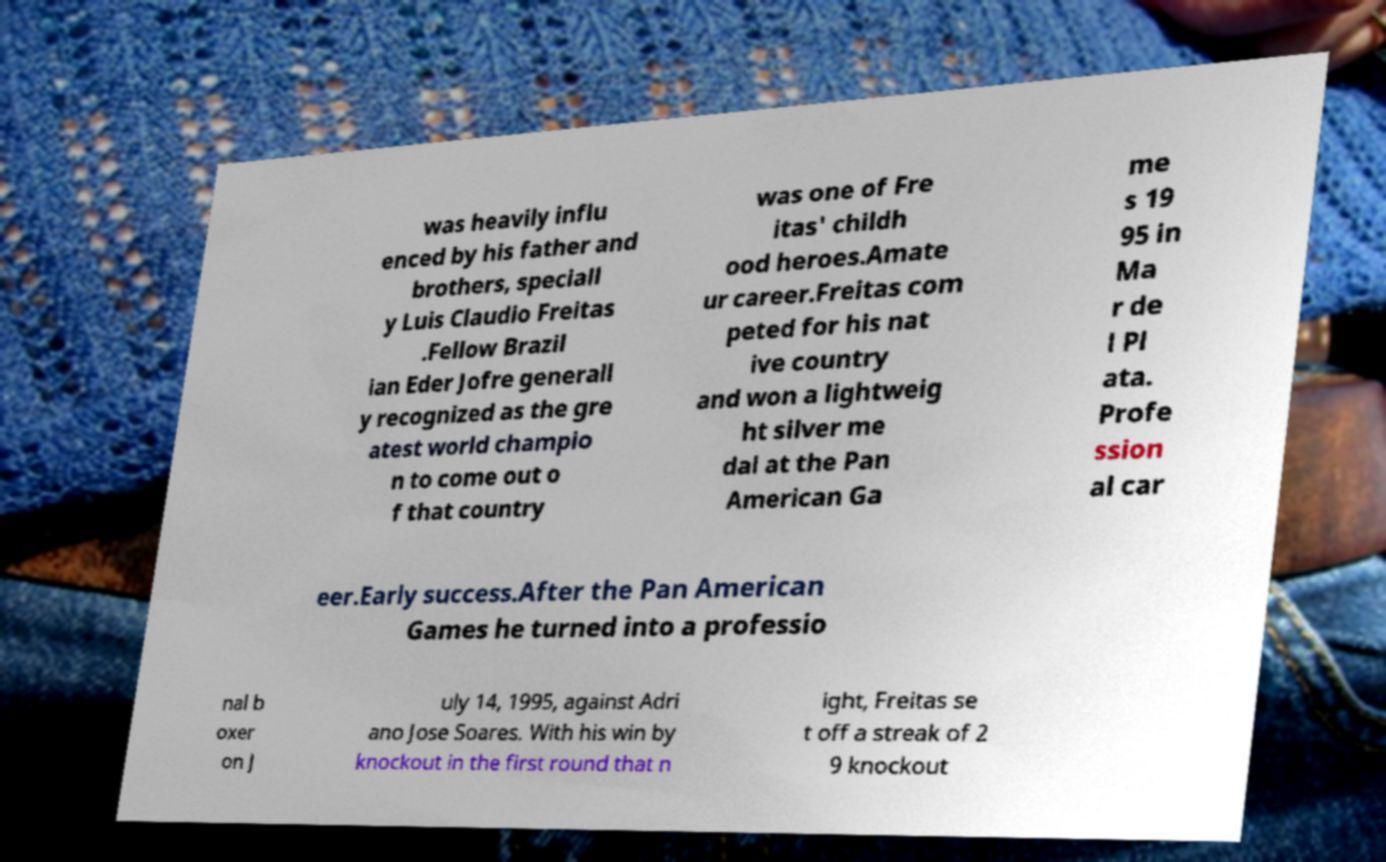Can you read and provide the text displayed in the image?This photo seems to have some interesting text. Can you extract and type it out for me? was heavily influ enced by his father and brothers, speciall y Luis Claudio Freitas .Fellow Brazil ian Eder Jofre generall y recognized as the gre atest world champio n to come out o f that country was one of Fre itas' childh ood heroes.Amate ur career.Freitas com peted for his nat ive country and won a lightweig ht silver me dal at the Pan American Ga me s 19 95 in Ma r de l Pl ata. Profe ssion al car eer.Early success.After the Pan American Games he turned into a professio nal b oxer on J uly 14, 1995, against Adri ano Jose Soares. With his win by knockout in the first round that n ight, Freitas se t off a streak of 2 9 knockout 